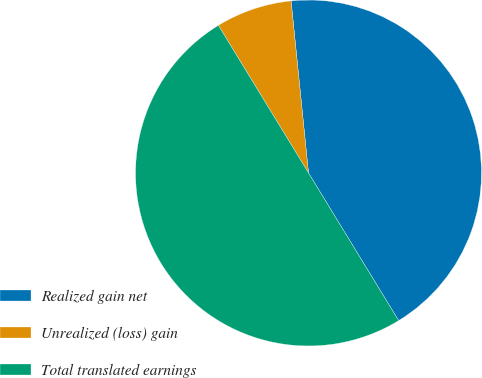Convert chart to OTSL. <chart><loc_0><loc_0><loc_500><loc_500><pie_chart><fcel>Realized gain net<fcel>Unrealized (loss) gain<fcel>Total translated earnings<nl><fcel>42.88%<fcel>7.12%<fcel>50.0%<nl></chart> 